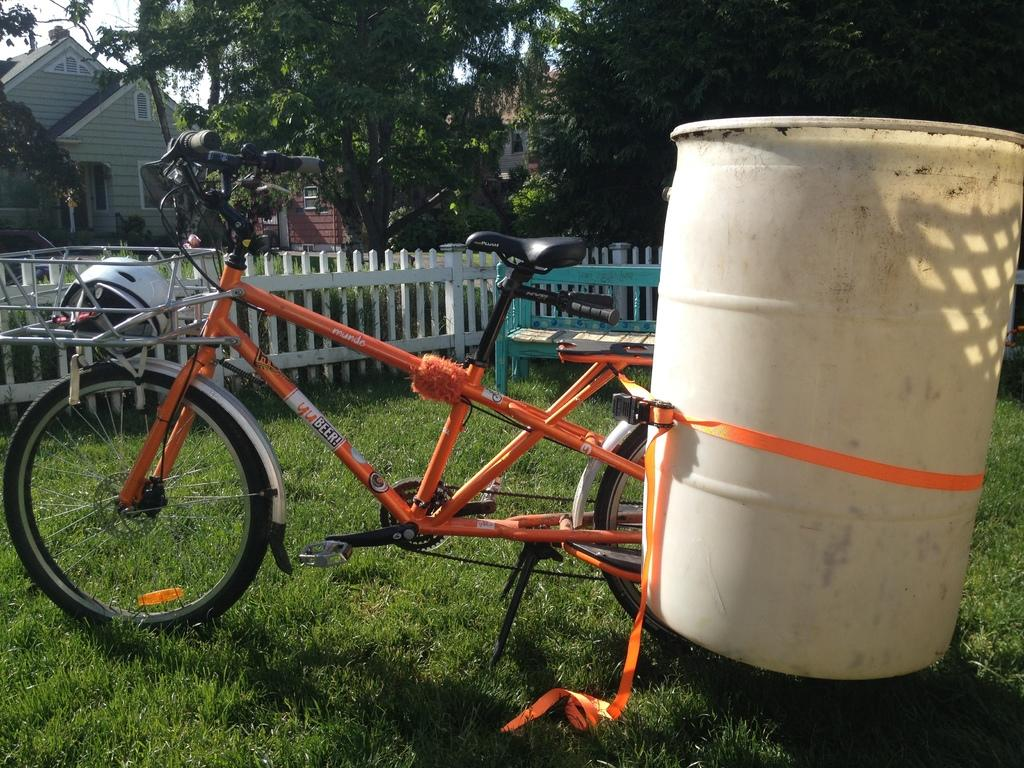What is the main object in the image? There is a bicycle in the image. What other objects can be seen in the image? There is a water drum, a fence, a bench, and grass visible in the image. What can be seen in the background of the image? There are trees, houses, and the sky visible in the background of the image. What type of work experience does the person sitting on the bench have in the image? There is no person sitting on the bench in the image, so it is not possible to determine their work experience. 